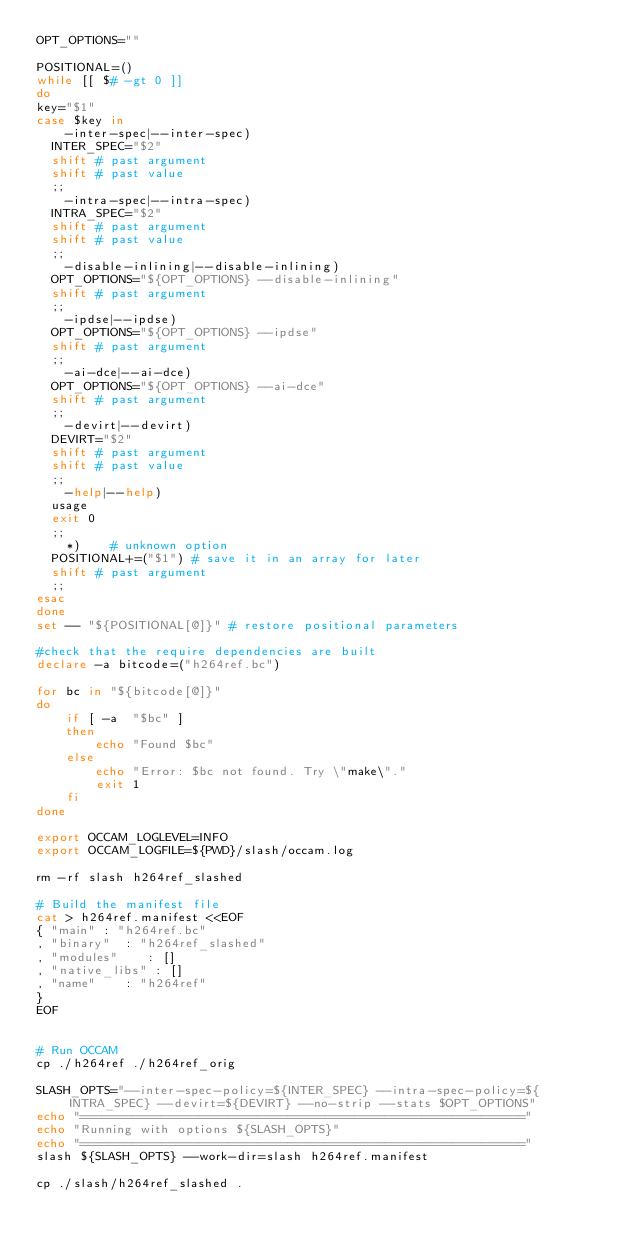Convert code to text. <code><loc_0><loc_0><loc_500><loc_500><_Bash_>OPT_OPTIONS=""

POSITIONAL=()
while [[ $# -gt 0 ]]
do
key="$1"
case $key in
    -inter-spec|--inter-spec)
	INTER_SPEC="$2"
	shift # past argument
	shift # past value
	;;
    -intra-spec|--intra-spec)
	INTRA_SPEC="$2"
	shift # past argument
	shift # past value
	;;
    -disable-inlining|--disable-inlining)
	OPT_OPTIONS="${OPT_OPTIONS} --disable-inlining"
	shift # past argument
	;;
    -ipdse|--ipdse)
	OPT_OPTIONS="${OPT_OPTIONS} --ipdse"
	shift # past argument
	;;
    -ai-dce|--ai-dce)
	OPT_OPTIONS="${OPT_OPTIONS} --ai-dce"
	shift # past argument
	;;        
    -devirt|--devirt)
	DEVIRT="$2"
	shift # past argument
	shift # past value
	;;            
    -help|--help)
	usage
	exit 0
	;;
    *)    # unknown option
	POSITIONAL+=("$1") # save it in an array for later
	shift # past argument
	;;
esac
done
set -- "${POSITIONAL[@]}" # restore positional parameters

#check that the require dependencies are built
declare -a bitcode=("h264ref.bc")

for bc in "${bitcode[@]}"
do
    if [ -a  "$bc" ]
    then
        echo "Found $bc"
    else
        echo "Error: $bc not found. Try \"make\"."
        exit 1
    fi
done

export OCCAM_LOGLEVEL=INFO
export OCCAM_LOGFILE=${PWD}/slash/occam.log

rm -rf slash h264ref_slashed

# Build the manifest file
cat > h264ref.manifest <<EOF
{ "main" : "h264ref.bc"
, "binary"  : "h264ref_slashed"
, "modules"    : []
, "native_libs" : []
, "name"    : "h264ref"
}
EOF


# Run OCCAM
cp ./h264ref ./h264ref_orig

SLASH_OPTS="--inter-spec-policy=${INTER_SPEC} --intra-spec-policy=${INTRA_SPEC} --devirt=${DEVIRT} --no-strip --stats $OPT_OPTIONS"
echo "============================================================"
echo "Running with options ${SLASH_OPTS}"
echo "============================================================"
slash ${SLASH_OPTS} --work-dir=slash h264ref.manifest

cp ./slash/h264ref_slashed .
</code> 